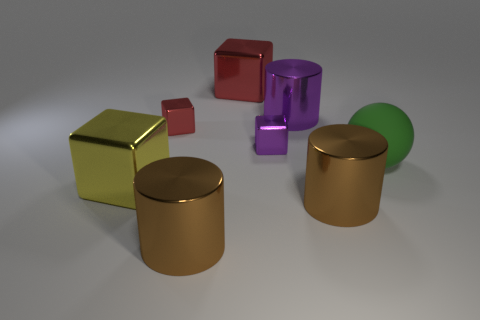Subtract all brown cylinders. How many cylinders are left? 1 Add 2 purple shiny cylinders. How many objects exist? 10 Subtract all yellow cubes. How many cubes are left? 3 Subtract all yellow cylinders. How many red cubes are left? 2 Subtract all cylinders. How many objects are left? 5 Subtract 1 balls. How many balls are left? 0 Subtract all yellow cylinders. Subtract all cyan balls. How many cylinders are left? 3 Subtract all large purple metallic cylinders. Subtract all tiny red shiny things. How many objects are left? 6 Add 7 yellow objects. How many yellow objects are left? 8 Add 4 tiny metallic cubes. How many tiny metallic cubes exist? 6 